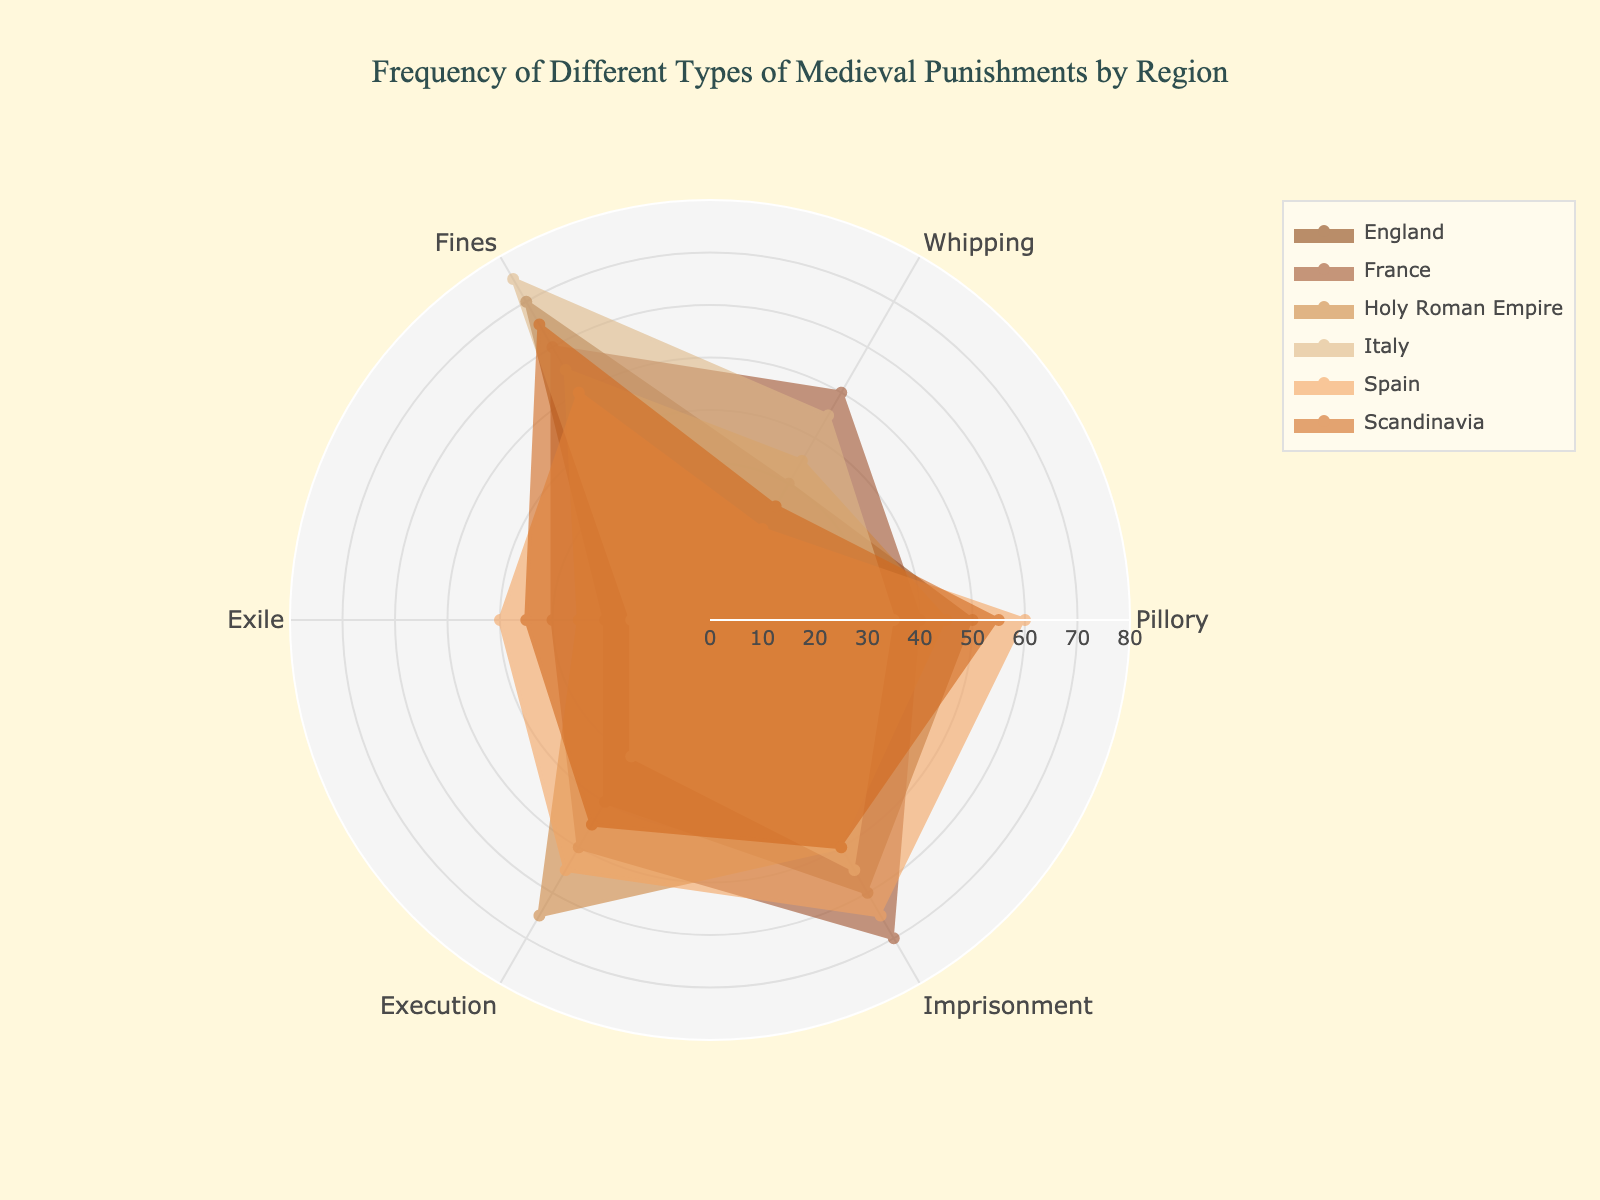what is the title of the chart? The title of the chart appears at the top center of the figure and reads "Frequency of Different Types of Medieval Punishments by Region."
Answer: Frequency of Different Types of Medieval Punishments by Region which region has the highest frequency of fines? To determine this, we look at the segment representing fines for each region and find the one with the highest value. Italy has a frequency of 75 for fines, which is the highest among the regions.
Answer: Italy how does the frequency of execution in Spain compare to France? By comparing the values for execution in both regions, we see that Spain has a frequency of 55, while France has a frequency of 50. Spain's frequency is higher.
Answer: Spain's frequency is higher which punishment type has the most consistent frequency across all regions? By examining each punishment type across the regions, we observe that imprisonment shows relatively similar values across regions, ranging from 50 to 70. Other punishment types have larger variations.
Answer: Imprisonment which region has the lowest frequency of exile? Looking at the exile values for each region, Italy has the lowest frequency of 15.
Answer: Italy what’s the average frequency of whipping across all regions? To find the average, add the frequency values for all regions (30 + 50 + 35 + 45 + 20 + 25 = 205) and then divide by the number of regions (6). The average frequency of whipping is 205/6 = 34.17.
Answer: 34.17 which region's radar plot has the largest area? The area of a radar plot is influenced by the frequency values across all punishment types. By examining the overall size and distribution of the plots, we see that England and France's plots cover wider areas compared to the others. However, a precise area calculation would require more detailed analysis.
Answer: England or France which punishment type shows the highest frequency overall? By identifying the highest values in each punishment type across all regions, we find that Fines in Italy has the highest frequency at 75.
Answer: Fines in Italy is there a region where the frequency of pillory is the highest among all types of punishment? By examining each region individually, we see that in Spain, Pillory (60) does not surpass Exile or Execution. Therefore, no region has the highest frequency with Pillory among all punishment types.
Answer: No compare the frequency of imprisonment in England to Holy Roman Empire England has an imprisonment frequency of 60, while the Holy Roman Empire has a frequency of 50. Therefore, England's frequency is higher by 10.
Answer: England's frequency is higher by 10 